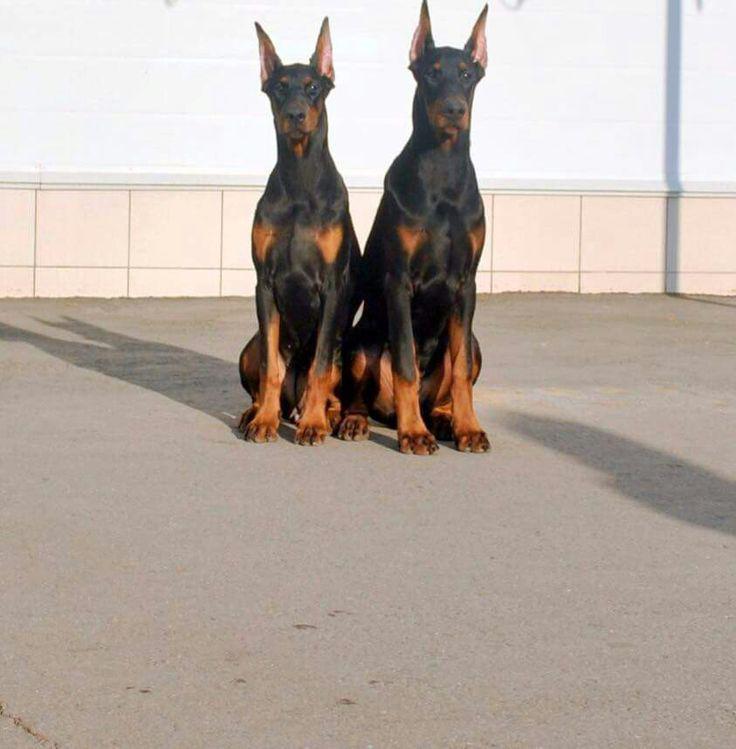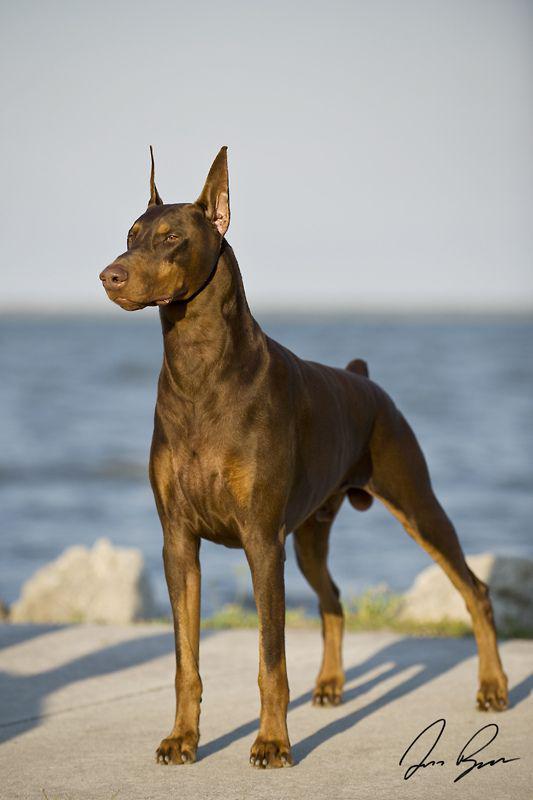The first image is the image on the left, the second image is the image on the right. Evaluate the accuracy of this statement regarding the images: "A doberman has its mouth open.". Is it true? Answer yes or no. No. The first image is the image on the left, the second image is the image on the right. Assess this claim about the two images: "All dogs shown have erect ears, each image contains one dog, the dog on the left is sitting upright, and the dog on the right is standing angled rightward.". Correct or not? Answer yes or no. No. 